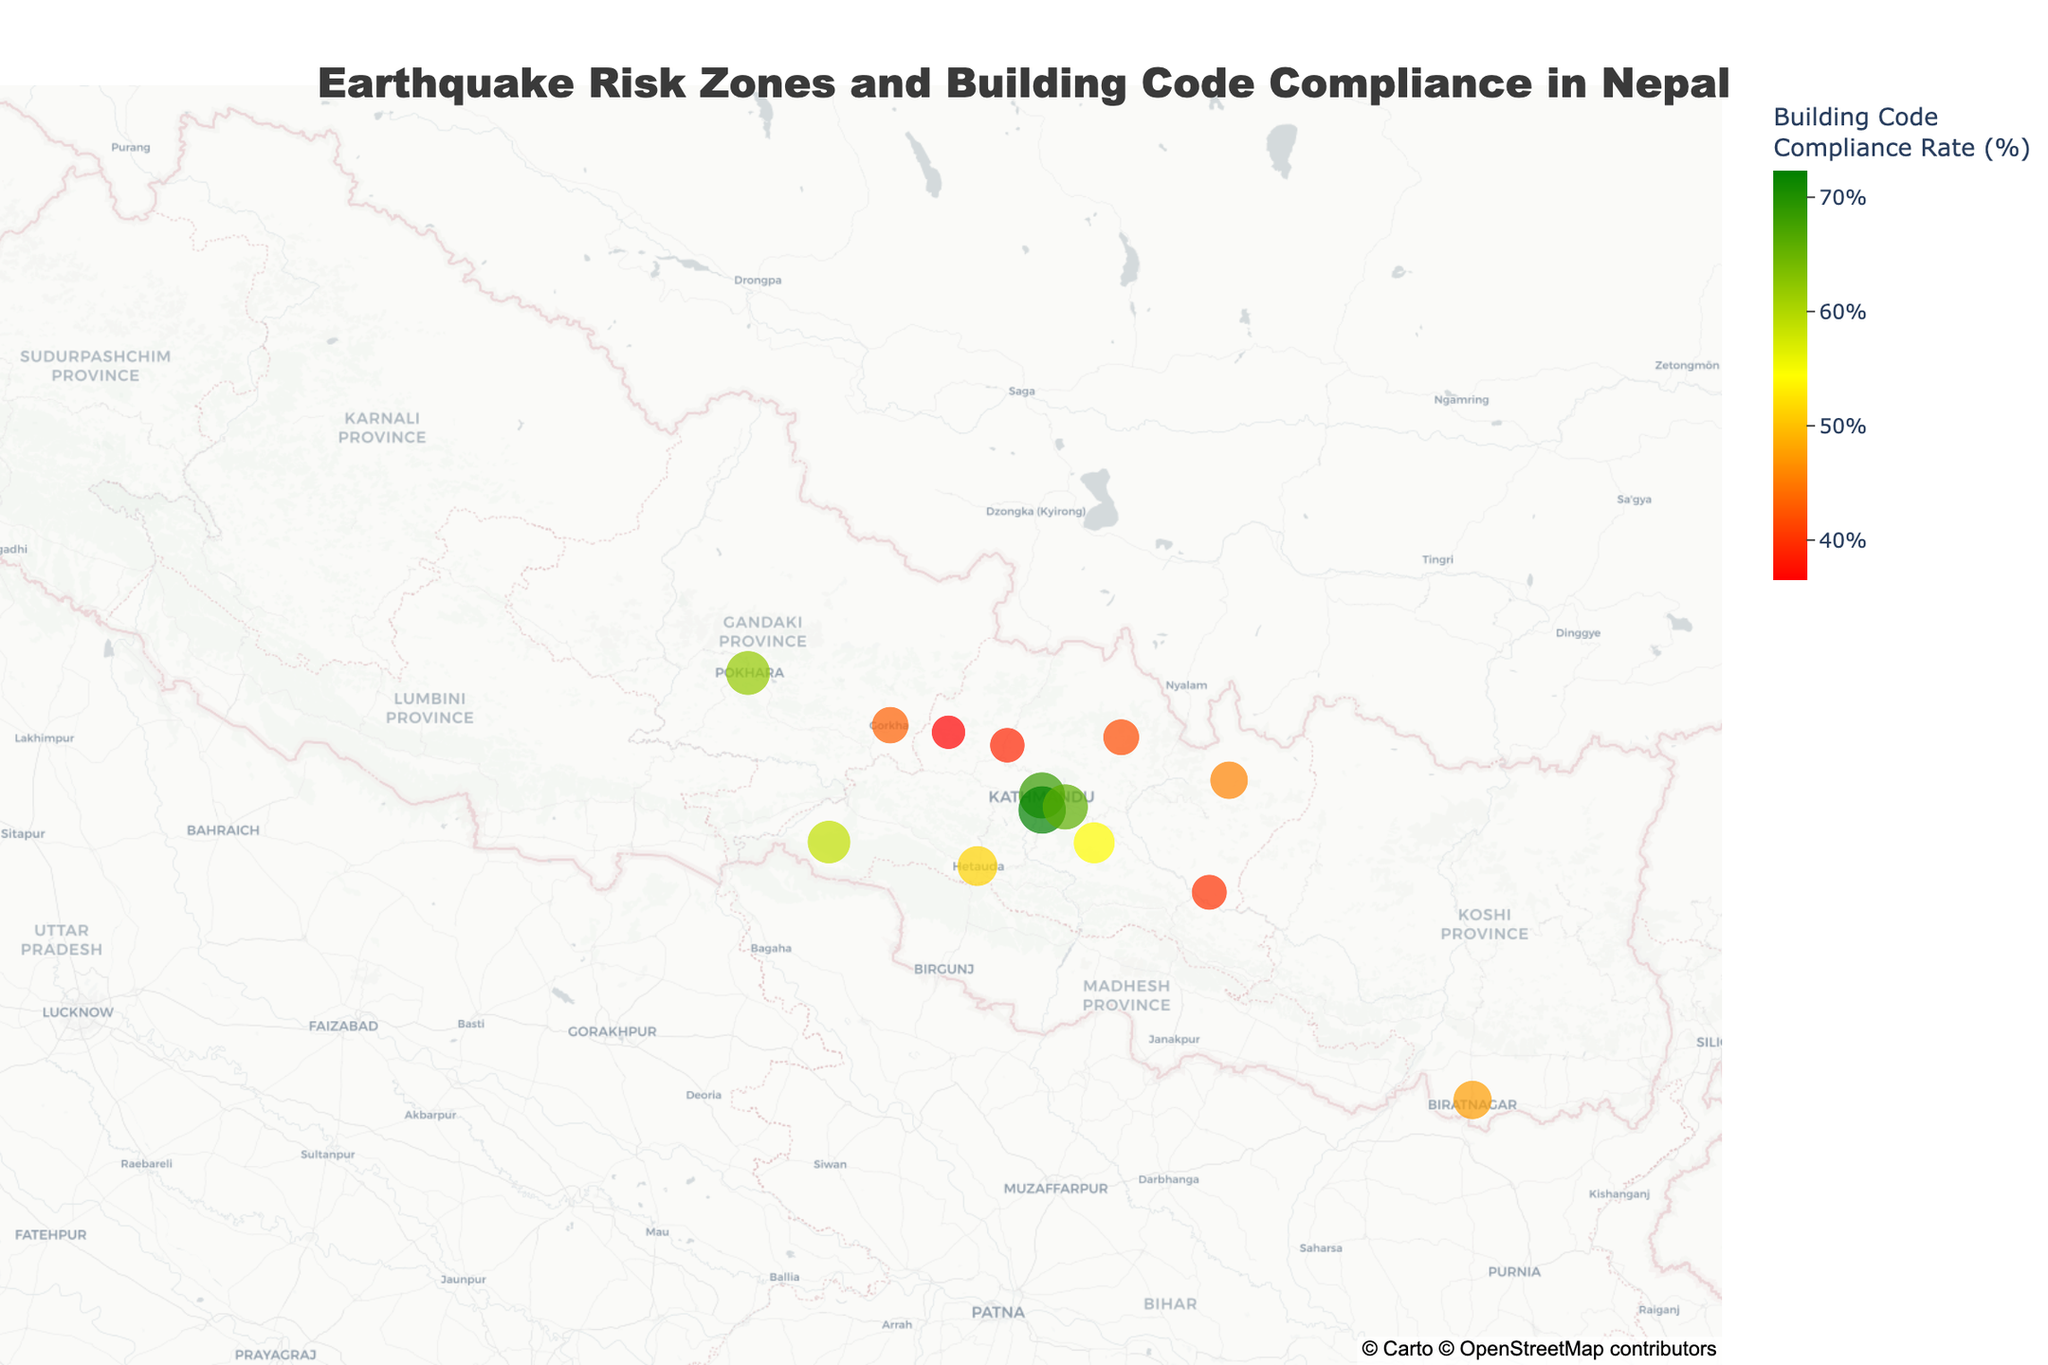What's the title of the figure? The title is typically displayed at the top of the figure to give a summary of what the figure represents. In this case, the title is "Earthquake Risk Zones and Building Code Compliance in Nepal" as described in the code.
Answer: Earthquake Risk Zones and Building Code Compliance in Nepal How many districts in the figure are classified as very high risk zones? To answer this, we count the number of data points with the "Risk_Zone" value as "Very High." These districts are Kathmandu, Lalitpur, Bhaktapur, Sindhupalchok, Gorkha, and Dolakha, totaling 6.
Answer: 6 Which district has the highest building code compliance rate and what is the rate? By examining the data points, the district with the highest compliance rate can be identified. Lalitpur has the highest rate, which is 72.3%.
Answer: Lalitpur, 72.3% What is the average building code compliance rate for districts categorized as high risk zones? To find this, first identify districts in high risk zones (Kavre, Nuwakot, Dhading, Pokhara). Sum their compliance rates (54.2 + 38.9 + 36.5 + 61.9 = 191.5), and then divide by the number of districts (191.5 / 4).
Answer: 47.9% How does the building code compliance rate in Kathmandu compare to that in Bhaktapur? By examining the compliance rates of the two districts, we see that Kathmandu has a compliance rate of 68.5% while Bhaktapur has 65.8%. Therefore, Kathmandu has a slightly higher rate.
Answer: Kathmandu is higher Which risk zone color represents low building code compliance rates? By referring to the color scale provided in the code, red indicates low compliance rates.
Answer: Red Is there any district in a moderate risk zone with a compliance rate over 55%? We first identify the districts in the moderate risk zone (Makwanpur, Chitwan). Chitwan has a compliance rate of 58.7%, which is over 55%.
Answer: Yes, Chitwan What is the compliance rate range for districts in the very high risk zone? Identify the minimum and maximum compliance rates in the very high risk zone (41.7% - Sindhupalchok to 72.3% - Lalitpur). The range is calculated as the difference between the highest and lowest rates (72.3 - 41.7).
Answer: 30.6% How many districts on the map fall within the moderate risk zone? Identifying from the data, Makwanpur and Chitwan are in the moderate risk zone, totaling 2 districts.
Answer: 2 What's the total number of districts represented on the figure? Count all districts listed in the data (Kathmandu, Lalitpur, Bhaktapur, Kavre, Sindhupalchok, Nuwakot, Dhading, Gorkha, Dolakha, Ramechhap, Makwanpur, Chitwan, Pokhara, Biratnagar), totaling 14.
Answer: 14 